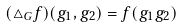Convert formula to latex. <formula><loc_0><loc_0><loc_500><loc_500>( \triangle _ { G } f ) ( g _ { 1 } , g _ { 2 } ) = f ( g _ { 1 } g _ { 2 } ) \,</formula> 